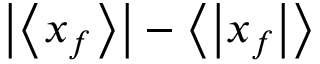<formula> <loc_0><loc_0><loc_500><loc_500>\left | \left < x _ { f } \right > \right | - \left < \left | x _ { f } \right | \right ></formula> 